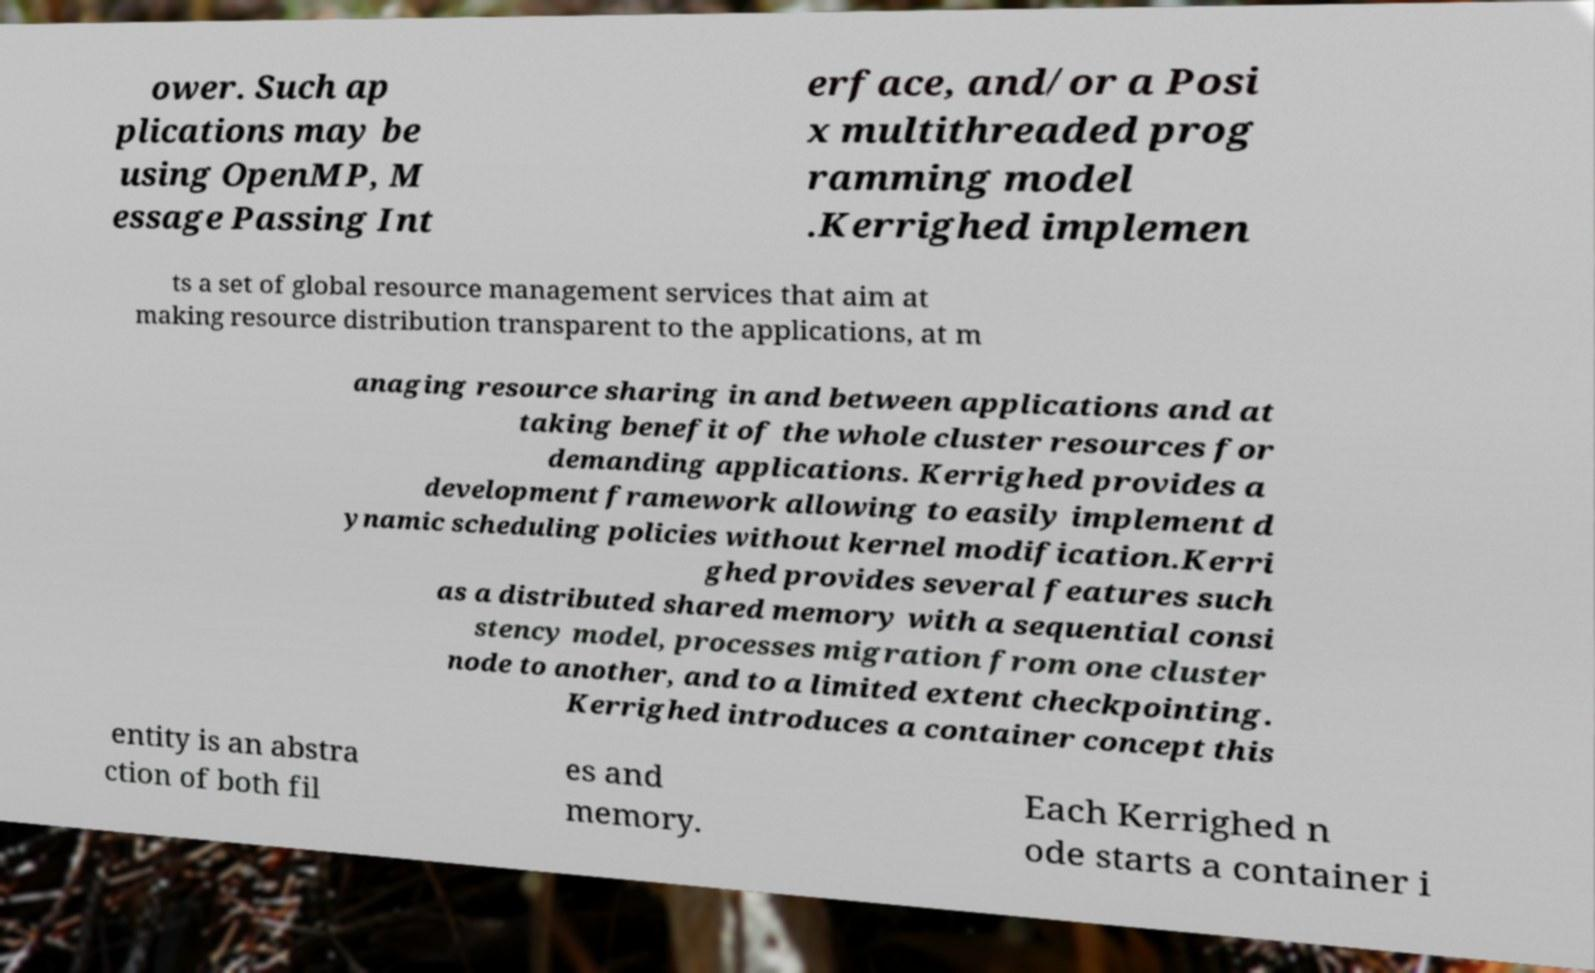Please read and relay the text visible in this image. What does it say? ower. Such ap plications may be using OpenMP, M essage Passing Int erface, and/or a Posi x multithreaded prog ramming model .Kerrighed implemen ts a set of global resource management services that aim at making resource distribution transparent to the applications, at m anaging resource sharing in and between applications and at taking benefit of the whole cluster resources for demanding applications. Kerrighed provides a development framework allowing to easily implement d ynamic scheduling policies without kernel modification.Kerri ghed provides several features such as a distributed shared memory with a sequential consi stency model, processes migration from one cluster node to another, and to a limited extent checkpointing. Kerrighed introduces a container concept this entity is an abstra ction of both fil es and memory. Each Kerrighed n ode starts a container i 